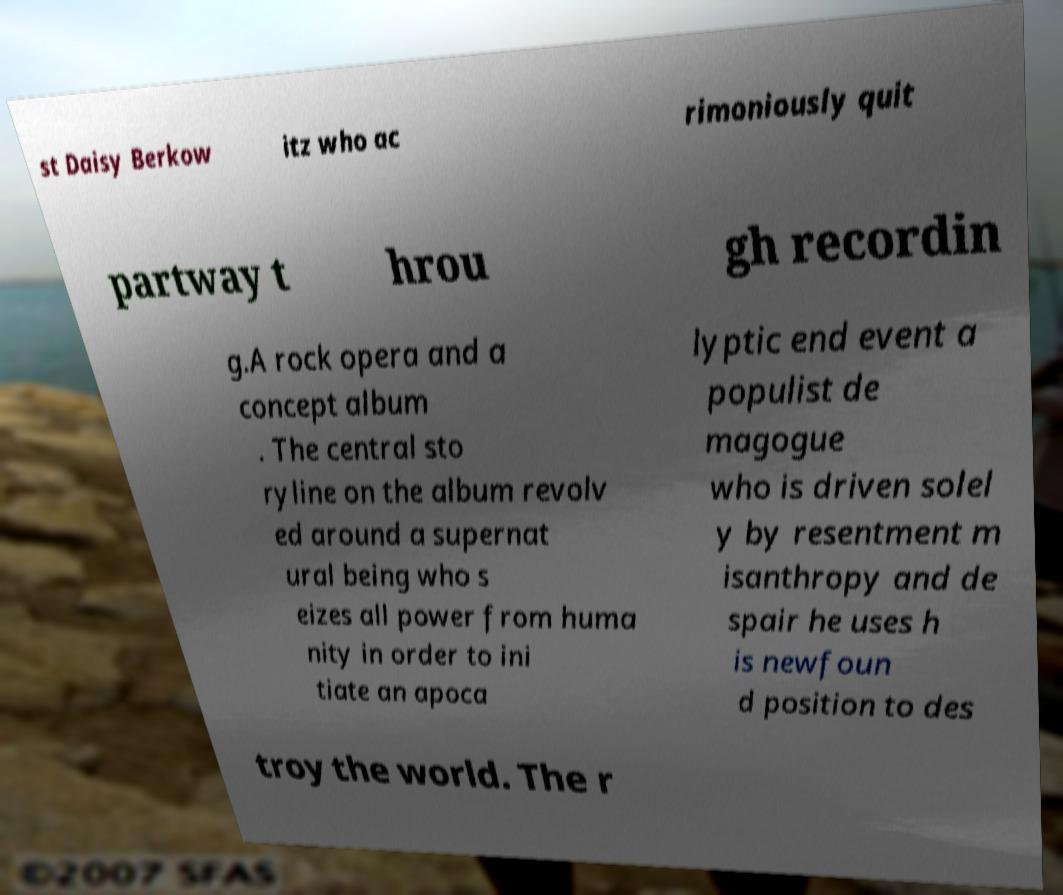Please identify and transcribe the text found in this image. st Daisy Berkow itz who ac rimoniously quit partway t hrou gh recordin g.A rock opera and a concept album . The central sto ryline on the album revolv ed around a supernat ural being who s eizes all power from huma nity in order to ini tiate an apoca lyptic end event a populist de magogue who is driven solel y by resentment m isanthropy and de spair he uses h is newfoun d position to des troy the world. The r 